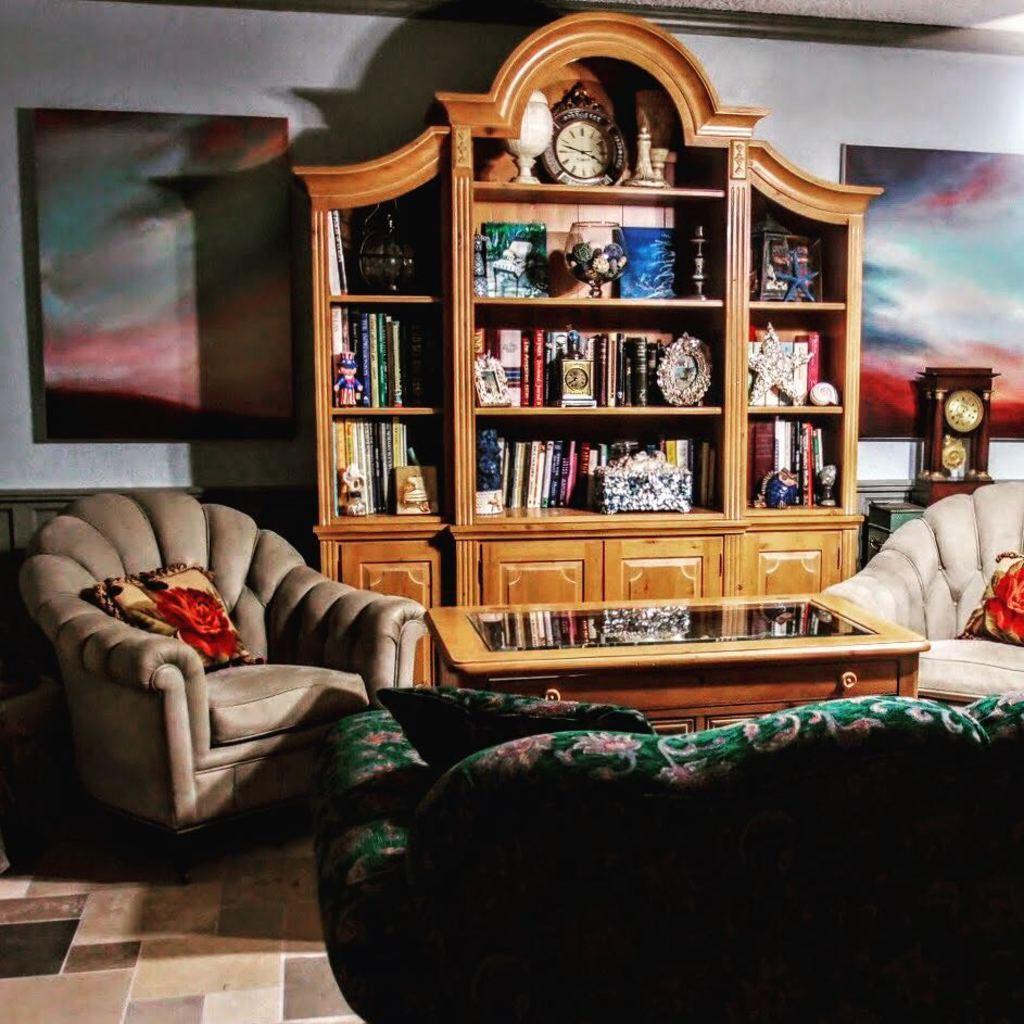In one or two sentences, can you explain what this image depicts? This picture describes about interior of the room, in this we can find couple of sofas, tables, and a clock on the table, and also we can see couple of books, shields, a clock and a flower vase in the racks, in the background we can see wall paintings on the wall. 